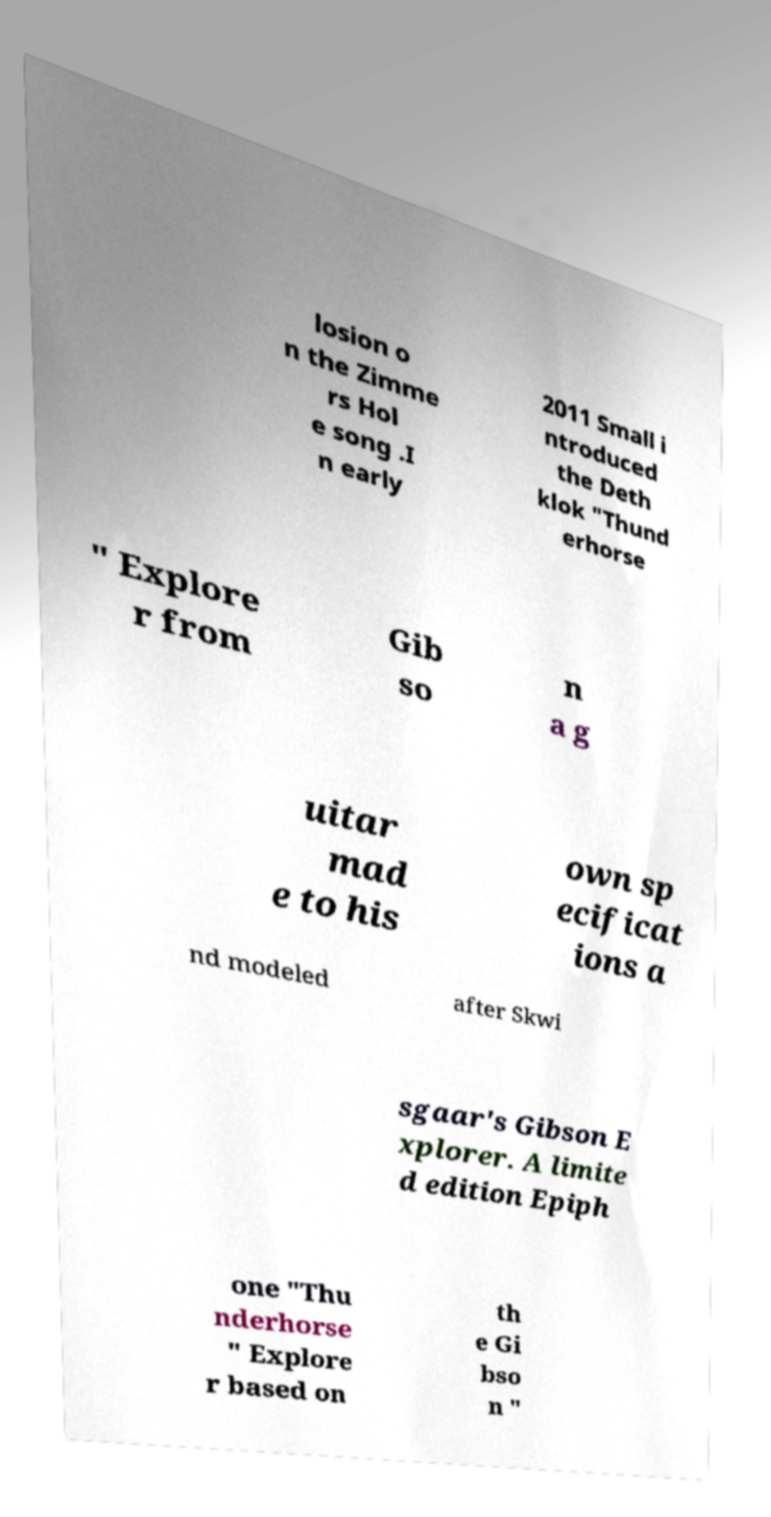For documentation purposes, I need the text within this image transcribed. Could you provide that? losion o n the Zimme rs Hol e song .I n early 2011 Small i ntroduced the Deth klok "Thund erhorse " Explore r from Gib so n a g uitar mad e to his own sp ecificat ions a nd modeled after Skwi sgaar's Gibson E xplorer. A limite d edition Epiph one "Thu nderhorse " Explore r based on th e Gi bso n " 